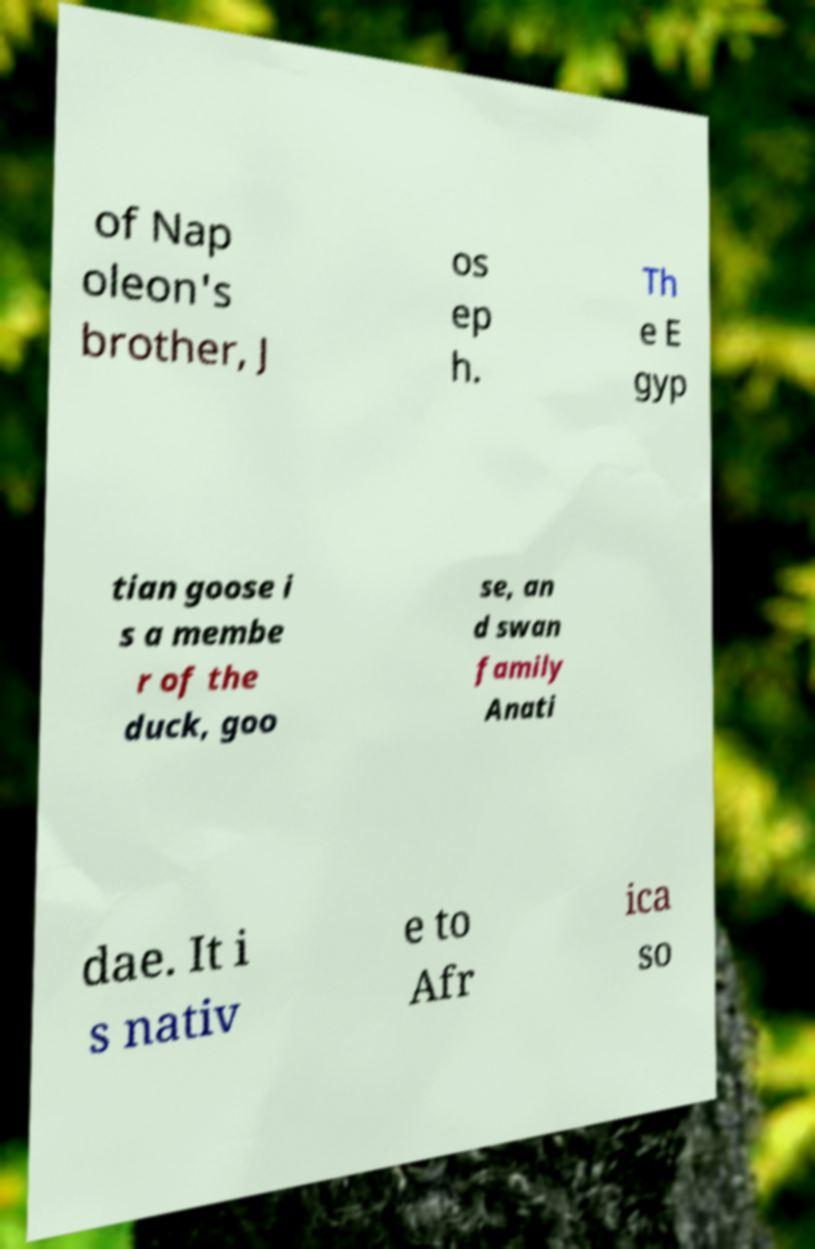What messages or text are displayed in this image? I need them in a readable, typed format. of Nap oleon's brother, J os ep h. Th e E gyp tian goose i s a membe r of the duck, goo se, an d swan family Anati dae. It i s nativ e to Afr ica so 